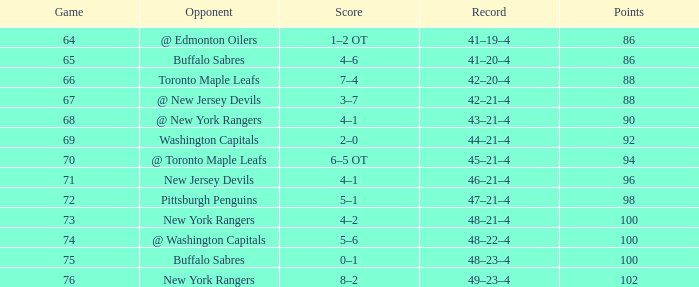Which Points have a Record of 45–21–4, and a Game larger than 70? None. 